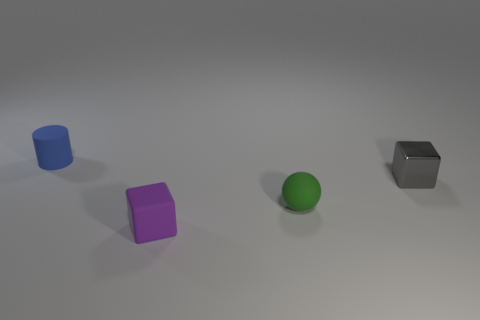There is a tiny green rubber thing to the left of the cube on the right side of the tiny purple object; are there any things to the right of it?
Keep it short and to the point. Yes. Is the material of the small cylinder the same as the green ball?
Offer a very short reply. Yes. Are there any other things that have the same shape as the green thing?
Keep it short and to the point. No. The tiny cube that is behind the small cube that is on the left side of the green rubber thing is made of what material?
Your answer should be very brief. Metal. There is a tiny thing that is on the left side of the tiny metallic thing and behind the ball; what color is it?
Keep it short and to the point. Blue. There is a rubber object behind the small green thing; is there a green thing in front of it?
Keep it short and to the point. Yes. What is the purple object made of?
Ensure brevity in your answer.  Rubber. There is a purple matte cube; are there any green spheres on the left side of it?
Provide a succinct answer. No. What is the size of the matte object that is the same shape as the gray metallic thing?
Your response must be concise. Small. Are there an equal number of purple rubber objects that are left of the small purple block and purple objects that are behind the small blue matte thing?
Make the answer very short. Yes. 